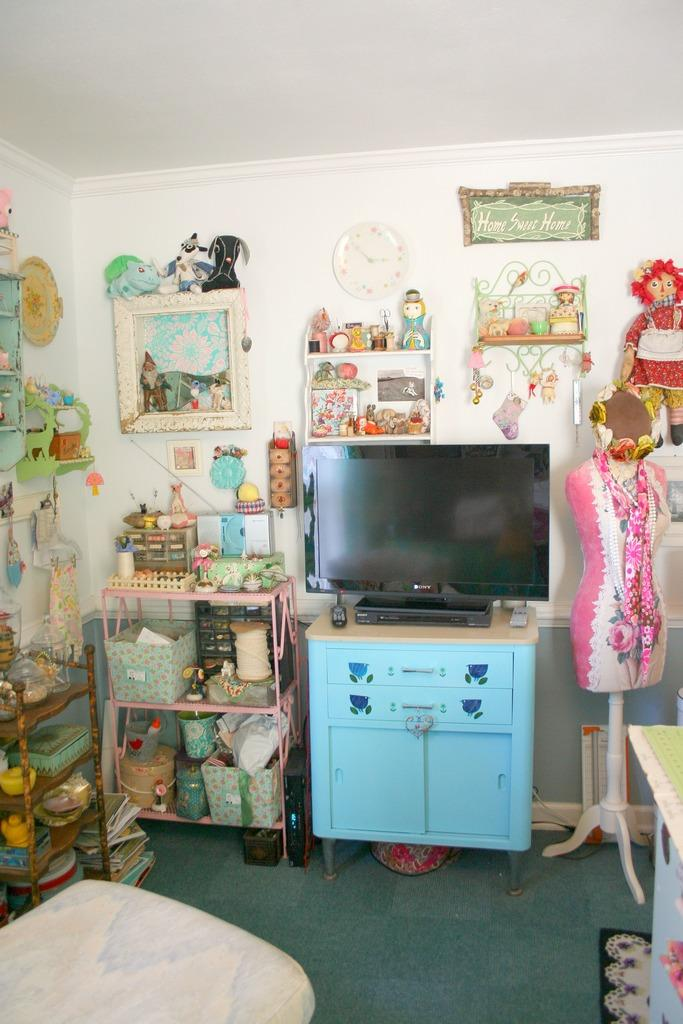<image>
Describe the image concisely. A quaint room with a sign that says Home Sweet Home on the wall. 